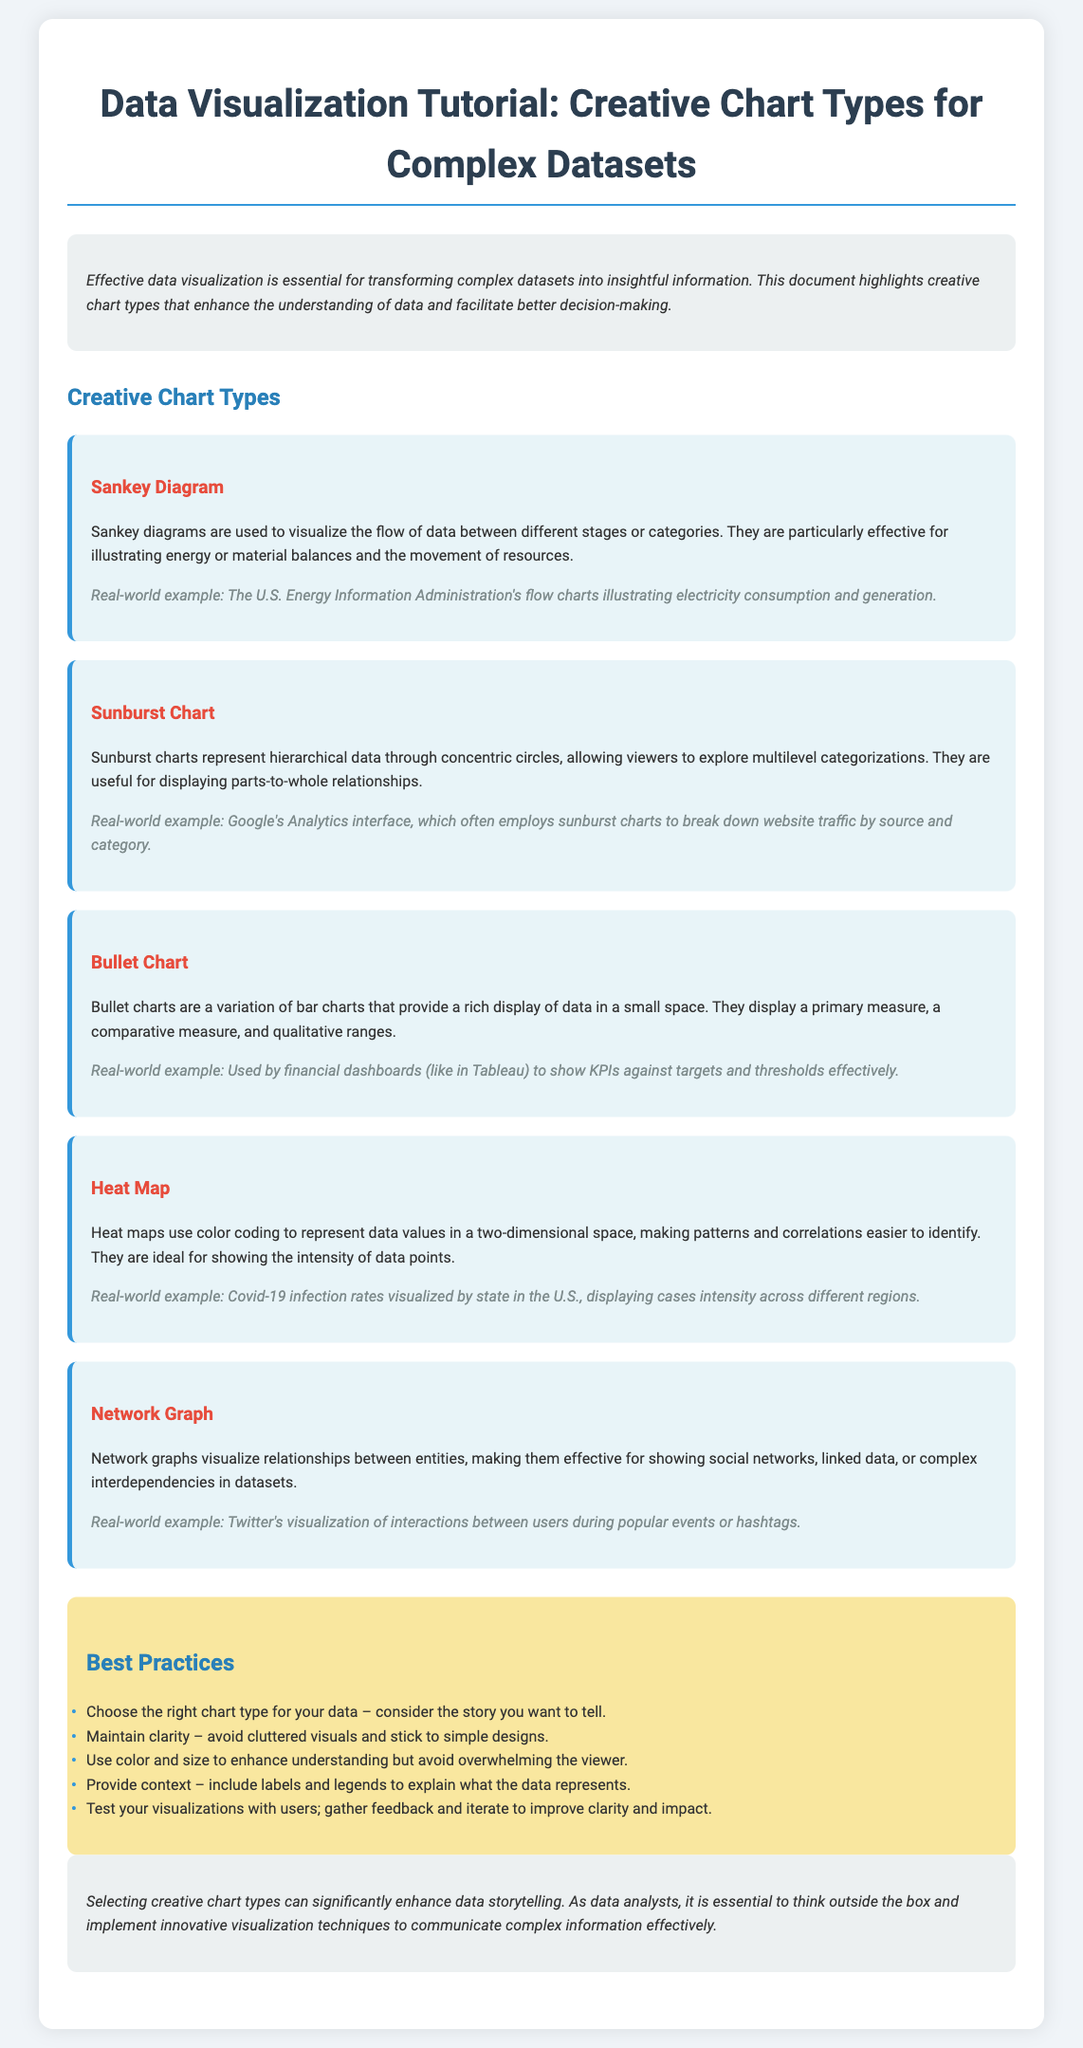What is the title of the document? The title is provided at the top of the document, describing the main focus of the content.
Answer: Creative Chart Types for Complex Datasets What chart type is used to visualize the flow of data? The document specifically describes a chart type that illustrates the flow of data between different stages or categories.
Answer: Sankey Diagram Which chart represents hierarchical data? The document lists a chart type that features concentric circles to show multilevel categorizations.
Answer: Sunburst Chart What example is provided for the heat map? The document contains a real-world example that illustrates how heat maps visualize a specific type of data.
Answer: Covid-19 infection rates Name one key best practice mentioned in the document. The document outlines specific best practices for creating effective visualizations.
Answer: Choose the right chart type Which chart type is a variation of bar charts? The document describes a chart that provides a rich display of data in a small space and is similar to bar charts.
Answer: Bullet Chart What is a common application of network graphs? The document illustrates the specific use case of a chart type that shows relationships between entities.
Answer: Social networks What is the purpose of data visualization according to the document? The introduction of the document highlights the main goal of effective data visualization.
Answer: Transforming complex datasets into insightful information 